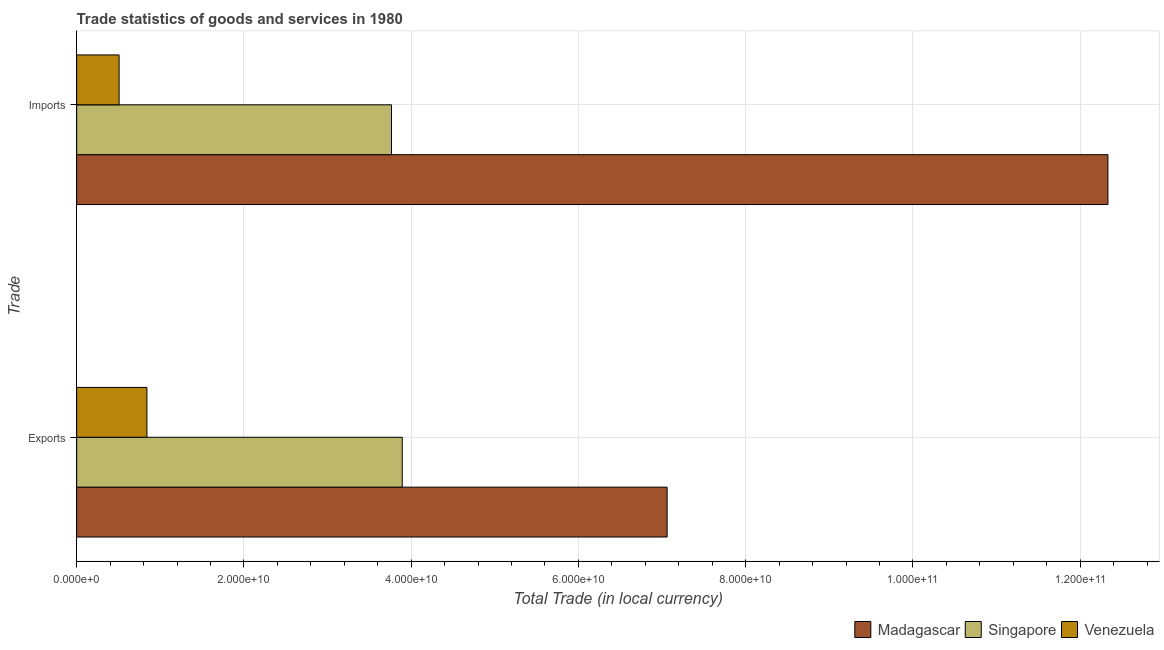How many different coloured bars are there?
Your answer should be compact. 3. How many groups of bars are there?
Offer a very short reply. 2. Are the number of bars per tick equal to the number of legend labels?
Ensure brevity in your answer.  Yes. Are the number of bars on each tick of the Y-axis equal?
Provide a short and direct response. Yes. How many bars are there on the 2nd tick from the top?
Make the answer very short. 3. How many bars are there on the 2nd tick from the bottom?
Keep it short and to the point. 3. What is the label of the 1st group of bars from the top?
Provide a short and direct response. Imports. What is the imports of goods and services in Venezuela?
Provide a short and direct response. 5.08e+09. Across all countries, what is the maximum imports of goods and services?
Your answer should be compact. 1.23e+11. Across all countries, what is the minimum imports of goods and services?
Your response must be concise. 5.08e+09. In which country was the export of goods and services maximum?
Provide a succinct answer. Madagascar. In which country was the imports of goods and services minimum?
Ensure brevity in your answer.  Venezuela. What is the total imports of goods and services in the graph?
Your answer should be very brief. 1.66e+11. What is the difference between the export of goods and services in Madagascar and that in Venezuela?
Your answer should be very brief. 6.22e+1. What is the difference between the imports of goods and services in Madagascar and the export of goods and services in Venezuela?
Your answer should be very brief. 1.15e+11. What is the average export of goods and services per country?
Ensure brevity in your answer.  3.93e+1. What is the difference between the export of goods and services and imports of goods and services in Venezuela?
Your answer should be very brief. 3.33e+09. In how many countries, is the imports of goods and services greater than 104000000000 LCU?
Ensure brevity in your answer.  1. What is the ratio of the imports of goods and services in Singapore to that in Madagascar?
Your answer should be compact. 0.31. Is the export of goods and services in Madagascar less than that in Singapore?
Offer a terse response. No. What does the 2nd bar from the top in Imports represents?
Your response must be concise. Singapore. What does the 2nd bar from the bottom in Exports represents?
Your answer should be compact. Singapore. How many bars are there?
Ensure brevity in your answer.  6. Are all the bars in the graph horizontal?
Your answer should be very brief. Yes. Are the values on the major ticks of X-axis written in scientific E-notation?
Offer a terse response. Yes. Where does the legend appear in the graph?
Offer a terse response. Bottom right. What is the title of the graph?
Provide a succinct answer. Trade statistics of goods and services in 1980. Does "Oman" appear as one of the legend labels in the graph?
Offer a terse response. No. What is the label or title of the X-axis?
Ensure brevity in your answer.  Total Trade (in local currency). What is the label or title of the Y-axis?
Provide a succinct answer. Trade. What is the Total Trade (in local currency) in Madagascar in Exports?
Ensure brevity in your answer.  7.06e+1. What is the Total Trade (in local currency) in Singapore in Exports?
Provide a short and direct response. 3.89e+1. What is the Total Trade (in local currency) in Venezuela in Exports?
Offer a terse response. 8.40e+09. What is the Total Trade (in local currency) of Madagascar in Imports?
Offer a terse response. 1.23e+11. What is the Total Trade (in local currency) in Singapore in Imports?
Your answer should be compact. 3.76e+1. What is the Total Trade (in local currency) in Venezuela in Imports?
Your response must be concise. 5.08e+09. Across all Trade, what is the maximum Total Trade (in local currency) of Madagascar?
Ensure brevity in your answer.  1.23e+11. Across all Trade, what is the maximum Total Trade (in local currency) of Singapore?
Offer a terse response. 3.89e+1. Across all Trade, what is the maximum Total Trade (in local currency) of Venezuela?
Your answer should be compact. 8.40e+09. Across all Trade, what is the minimum Total Trade (in local currency) in Madagascar?
Offer a very short reply. 7.06e+1. Across all Trade, what is the minimum Total Trade (in local currency) of Singapore?
Ensure brevity in your answer.  3.76e+1. Across all Trade, what is the minimum Total Trade (in local currency) of Venezuela?
Your answer should be very brief. 5.08e+09. What is the total Total Trade (in local currency) of Madagascar in the graph?
Offer a very short reply. 1.94e+11. What is the total Total Trade (in local currency) of Singapore in the graph?
Your response must be concise. 7.66e+1. What is the total Total Trade (in local currency) of Venezuela in the graph?
Provide a short and direct response. 1.35e+1. What is the difference between the Total Trade (in local currency) in Madagascar in Exports and that in Imports?
Your answer should be compact. -5.27e+1. What is the difference between the Total Trade (in local currency) in Singapore in Exports and that in Imports?
Offer a terse response. 1.28e+09. What is the difference between the Total Trade (in local currency) in Venezuela in Exports and that in Imports?
Offer a terse response. 3.33e+09. What is the difference between the Total Trade (in local currency) of Madagascar in Exports and the Total Trade (in local currency) of Singapore in Imports?
Offer a very short reply. 3.30e+1. What is the difference between the Total Trade (in local currency) of Madagascar in Exports and the Total Trade (in local currency) of Venezuela in Imports?
Provide a succinct answer. 6.55e+1. What is the difference between the Total Trade (in local currency) in Singapore in Exports and the Total Trade (in local currency) in Venezuela in Imports?
Provide a succinct answer. 3.39e+1. What is the average Total Trade (in local currency) of Madagascar per Trade?
Provide a succinct answer. 9.70e+1. What is the average Total Trade (in local currency) of Singapore per Trade?
Keep it short and to the point. 3.83e+1. What is the average Total Trade (in local currency) of Venezuela per Trade?
Your response must be concise. 6.74e+09. What is the difference between the Total Trade (in local currency) of Madagascar and Total Trade (in local currency) of Singapore in Exports?
Make the answer very short. 3.17e+1. What is the difference between the Total Trade (in local currency) in Madagascar and Total Trade (in local currency) in Venezuela in Exports?
Offer a terse response. 6.22e+1. What is the difference between the Total Trade (in local currency) in Singapore and Total Trade (in local currency) in Venezuela in Exports?
Your answer should be compact. 3.05e+1. What is the difference between the Total Trade (in local currency) of Madagascar and Total Trade (in local currency) of Singapore in Imports?
Make the answer very short. 8.57e+1. What is the difference between the Total Trade (in local currency) in Madagascar and Total Trade (in local currency) in Venezuela in Imports?
Provide a short and direct response. 1.18e+11. What is the difference between the Total Trade (in local currency) in Singapore and Total Trade (in local currency) in Venezuela in Imports?
Provide a short and direct response. 3.26e+1. What is the ratio of the Total Trade (in local currency) in Madagascar in Exports to that in Imports?
Provide a succinct answer. 0.57. What is the ratio of the Total Trade (in local currency) of Singapore in Exports to that in Imports?
Offer a terse response. 1.03. What is the ratio of the Total Trade (in local currency) in Venezuela in Exports to that in Imports?
Your response must be concise. 1.66. What is the difference between the highest and the second highest Total Trade (in local currency) of Madagascar?
Offer a terse response. 5.27e+1. What is the difference between the highest and the second highest Total Trade (in local currency) of Singapore?
Provide a short and direct response. 1.28e+09. What is the difference between the highest and the second highest Total Trade (in local currency) in Venezuela?
Provide a succinct answer. 3.33e+09. What is the difference between the highest and the lowest Total Trade (in local currency) in Madagascar?
Offer a terse response. 5.27e+1. What is the difference between the highest and the lowest Total Trade (in local currency) in Singapore?
Offer a terse response. 1.28e+09. What is the difference between the highest and the lowest Total Trade (in local currency) of Venezuela?
Give a very brief answer. 3.33e+09. 